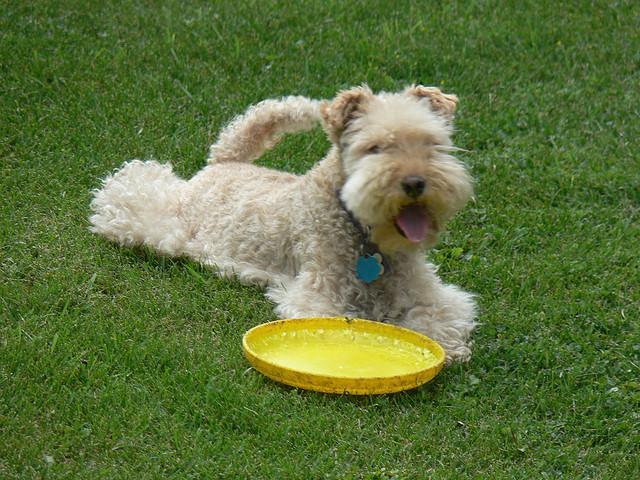Is the dog smiling?
Concise answer only. Yes. Is the dog wearing any tags?
Be succinct. Yes. What type of animal is this?
Quick response, please. Dog. 